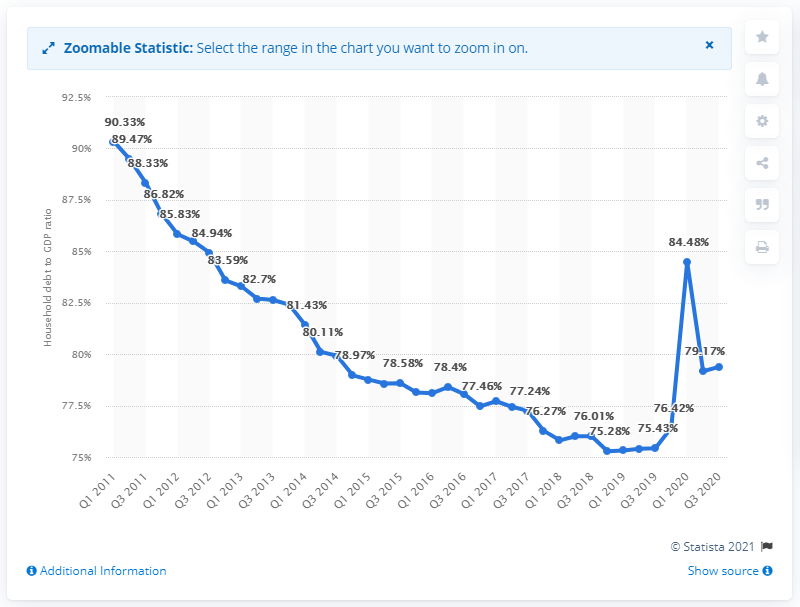Highlight a few significant elements in this photo. The US household debt to GDP ratio in the third quarter of 2020 was 79.38. 